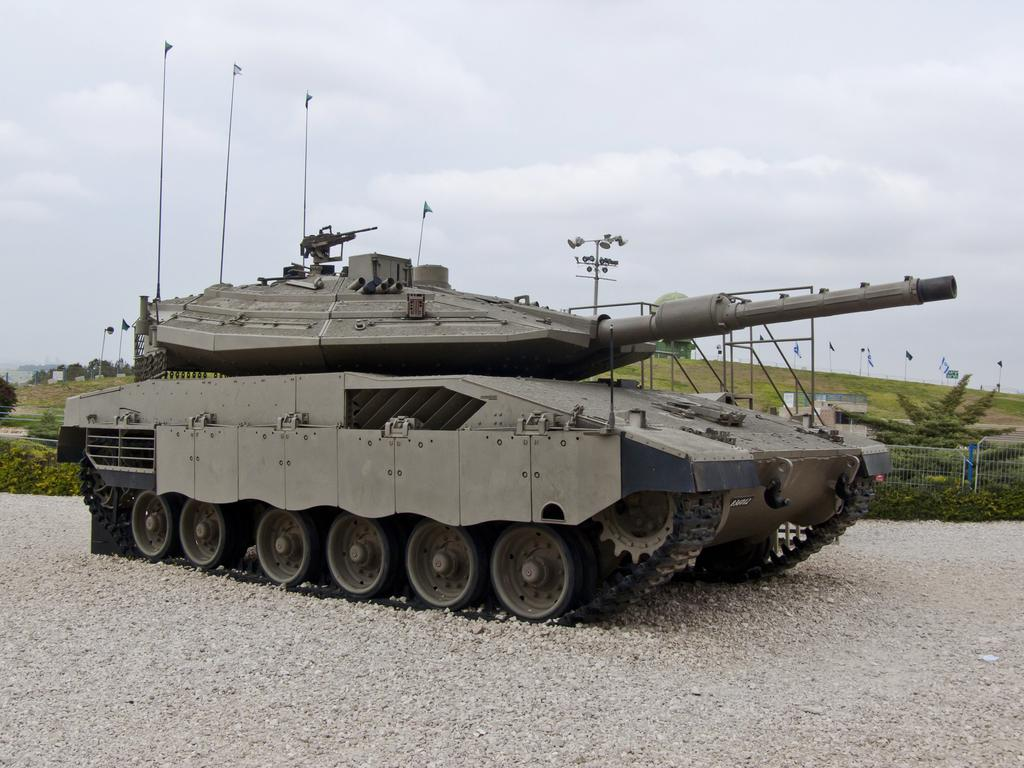What type of vehicle is on the ground in the image? There is a war tank on the ground in the image. What can be seen in the image besides the war tank? There is a fence, trees, poles, flags, and some objects in the image. What is the purpose of the poles in the image? The poles may be used for supporting flags or other objects. What is visible in the background of the image? The sky is visible in the background of the image. What type of behavior can be observed in the branch of the tree in the image? There is no branch of a tree visible in the image, and therefore no behavior can be observed. 